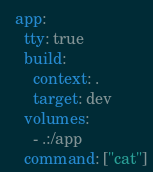<code> <loc_0><loc_0><loc_500><loc_500><_YAML_>
  app:
    tty: true
    build:
      context: .
      target: dev
    volumes:
      - .:/app
    command: ["cat"]
</code> 